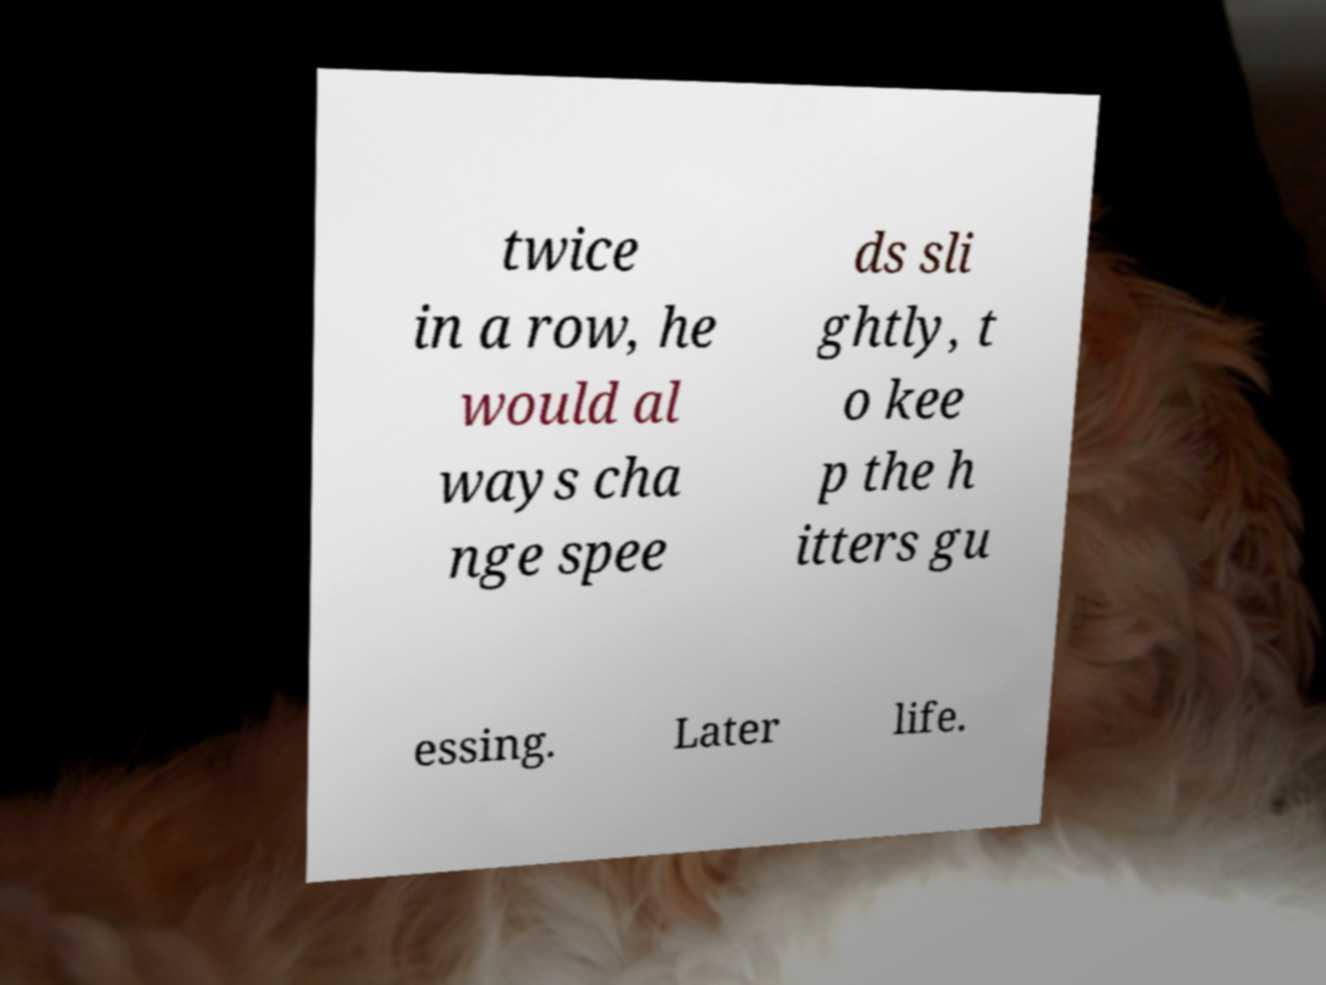I need the written content from this picture converted into text. Can you do that? twice in a row, he would al ways cha nge spee ds sli ghtly, t o kee p the h itters gu essing. Later life. 